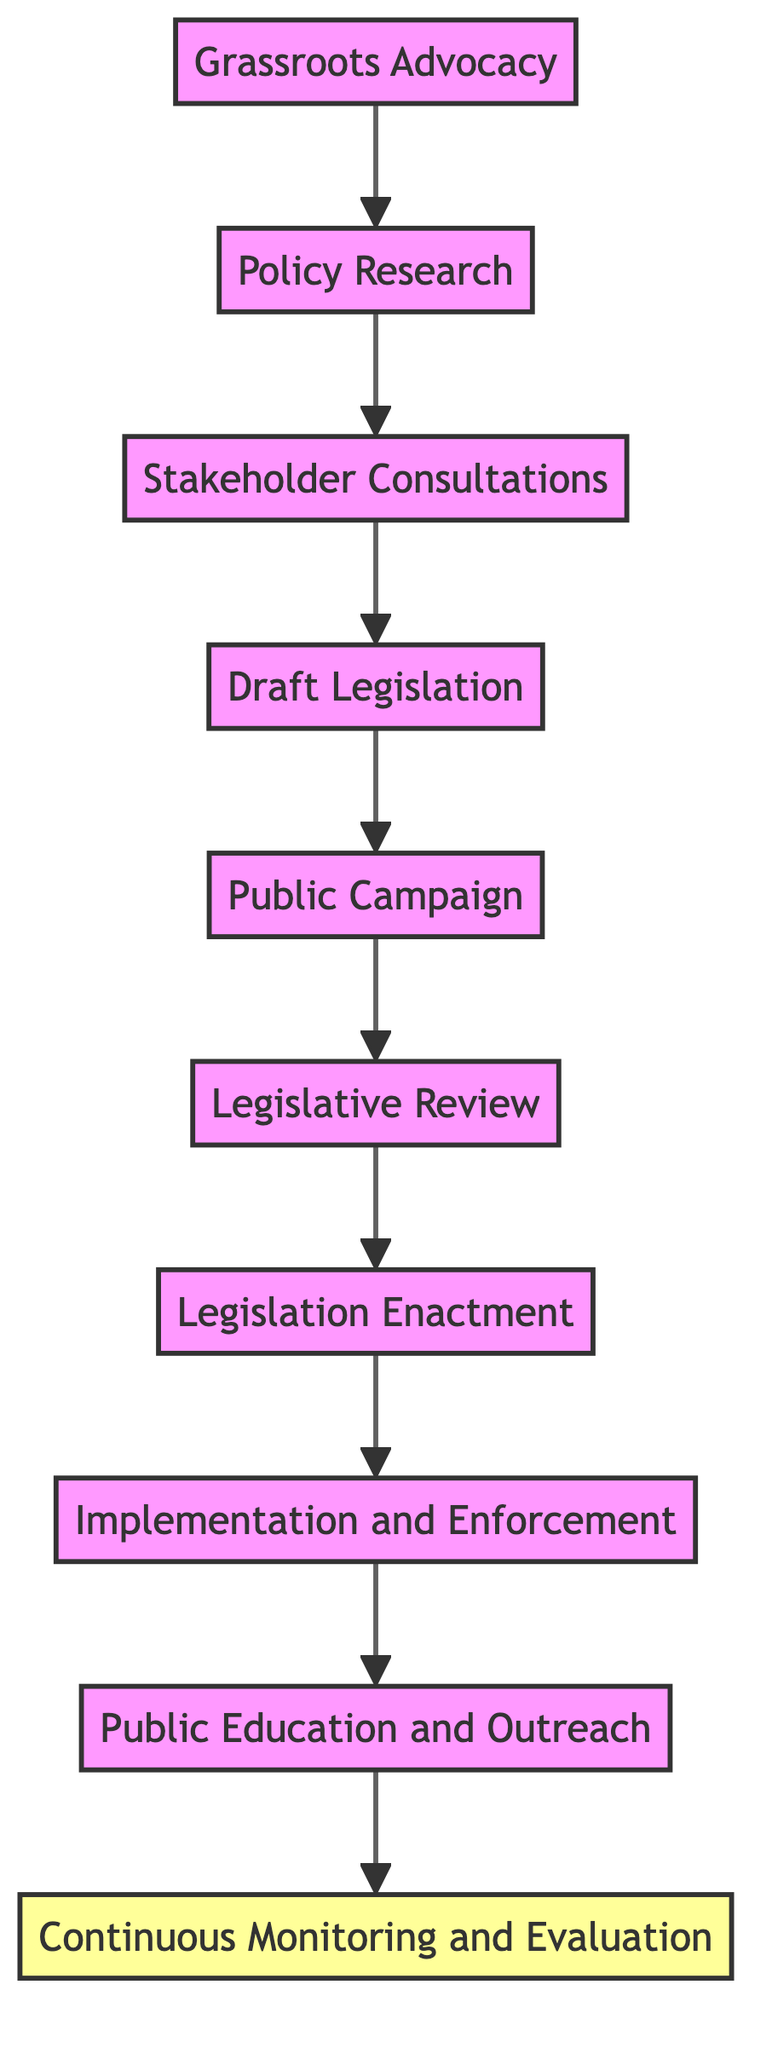What is the first step in developing horse protection laws? The diagram indicates that the first step is "Grassroots Advocacy," which is the initial phase before going into research and consultations.
Answer: Grassroots Advocacy How many steps are in this diagram? By counting the nodes from "Grassroots Advocacy" to "Continuous Monitoring and Evaluation," we see there are 10 steps in total.
Answer: 10 What flow follows the "Draft Legislation"? From "Draft Legislation," the flow progresses to "Public Campaign," indicating that public awareness follows the drafting stage.
Answer: Public Campaign Which step comes directly after "Legislation Enactment"? The step that follows "Legislation Enactment" in the diagram is "Implementation and Enforcement," showing the transition from laws being passed to their enforcement.
Answer: Implementation and Enforcement What type of activities are involved in "Public Campaign"? The description for "Public Campaign" specifies it includes educating the community on the importance of the new horse protection laws, indicating that awareness and education activities are involved.
Answer: Educating the community How does "Continuous Monitoring and Evaluation" relate to the earlier steps? "Continuous Monitoring and Evaluation" is the final step that gathers feedback and assesses the effectiveness of the implemented laws, highlighting its connection with all previous steps focused on law development and implementation.
Answer: It evaluates all previous steps What is the purpose of "Stakeholder Consultations"? The purpose of "Stakeholder Consultations" is to gather comprehensive input from various groups, ensuring that the legislation is informed by diverse perspectives.
Answer: Gather comprehensive input Which step requires collaboration with legal advisors? The step that requires collaboration with legal advisors is "Draft Legislation," as it involves drafting new laws based on identified gaps and stakeholder input.
Answer: Draft Legislation What action is emphasized in "Implementation and Enforcement"? The emphasis in "Implementation and Enforcement" is on overseeing the development of implementation guidelines and training of enforcement personnel to ensure the new laws are properly enforced.
Answer: Develop guidelines and train personnel 